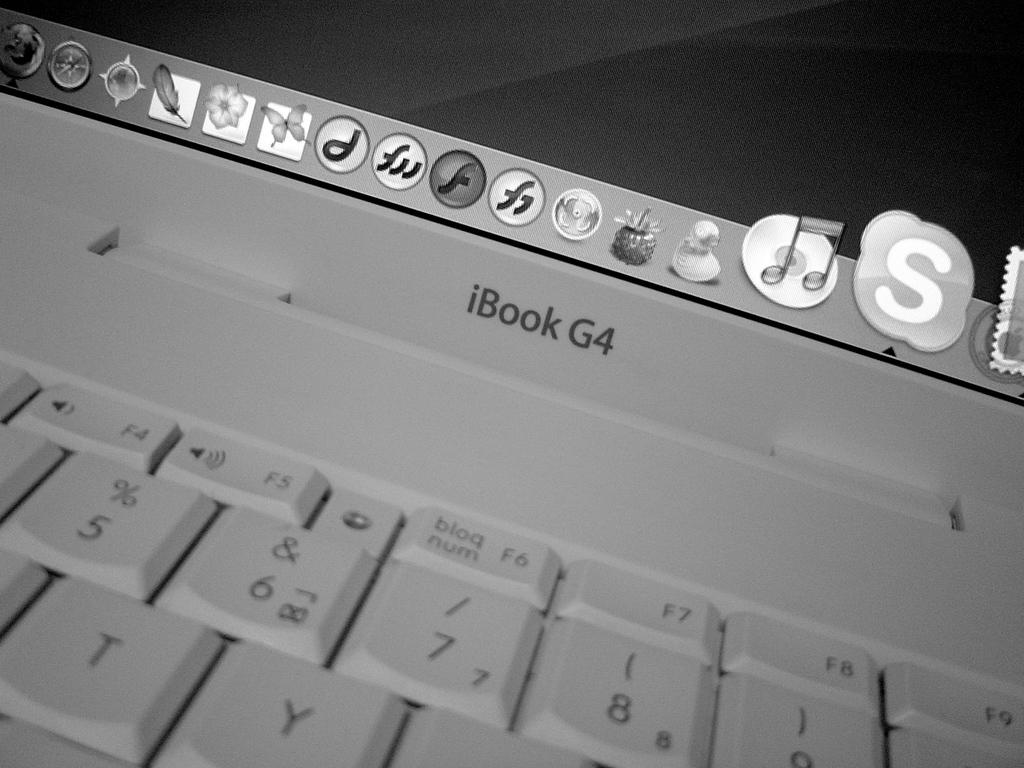<image>
Share a concise interpretation of the image provided. The laptop in the image is an iBook G4 